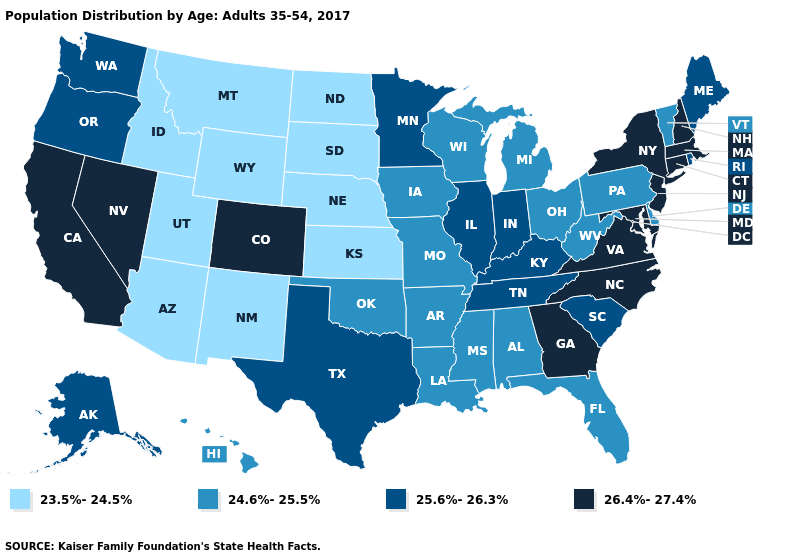Does the first symbol in the legend represent the smallest category?
Write a very short answer. Yes. What is the value of Oklahoma?
Concise answer only. 24.6%-25.5%. What is the highest value in states that border Maine?
Short answer required. 26.4%-27.4%. Does South Dakota have a higher value than Connecticut?
Be succinct. No. Name the states that have a value in the range 26.4%-27.4%?
Answer briefly. California, Colorado, Connecticut, Georgia, Maryland, Massachusetts, Nevada, New Hampshire, New Jersey, New York, North Carolina, Virginia. Among the states that border New York , which have the highest value?
Answer briefly. Connecticut, Massachusetts, New Jersey. How many symbols are there in the legend?
Keep it brief. 4. Name the states that have a value in the range 24.6%-25.5%?
Answer briefly. Alabama, Arkansas, Delaware, Florida, Hawaii, Iowa, Louisiana, Michigan, Mississippi, Missouri, Ohio, Oklahoma, Pennsylvania, Vermont, West Virginia, Wisconsin. Which states hav the highest value in the MidWest?
Concise answer only. Illinois, Indiana, Minnesota. Name the states that have a value in the range 25.6%-26.3%?
Answer briefly. Alaska, Illinois, Indiana, Kentucky, Maine, Minnesota, Oregon, Rhode Island, South Carolina, Tennessee, Texas, Washington. Does New Jersey have a higher value than North Carolina?
Short answer required. No. What is the value of Kentucky?
Short answer required. 25.6%-26.3%. Does North Carolina have a higher value than Massachusetts?
Keep it brief. No. What is the value of Colorado?
Quick response, please. 26.4%-27.4%. Does Maryland have the highest value in the South?
Write a very short answer. Yes. 